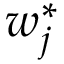<formula> <loc_0><loc_0><loc_500><loc_500>w _ { j } ^ { * }</formula> 